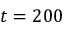Convert formula to latex. <formula><loc_0><loc_0><loc_500><loc_500>t = 2 0 0</formula> 